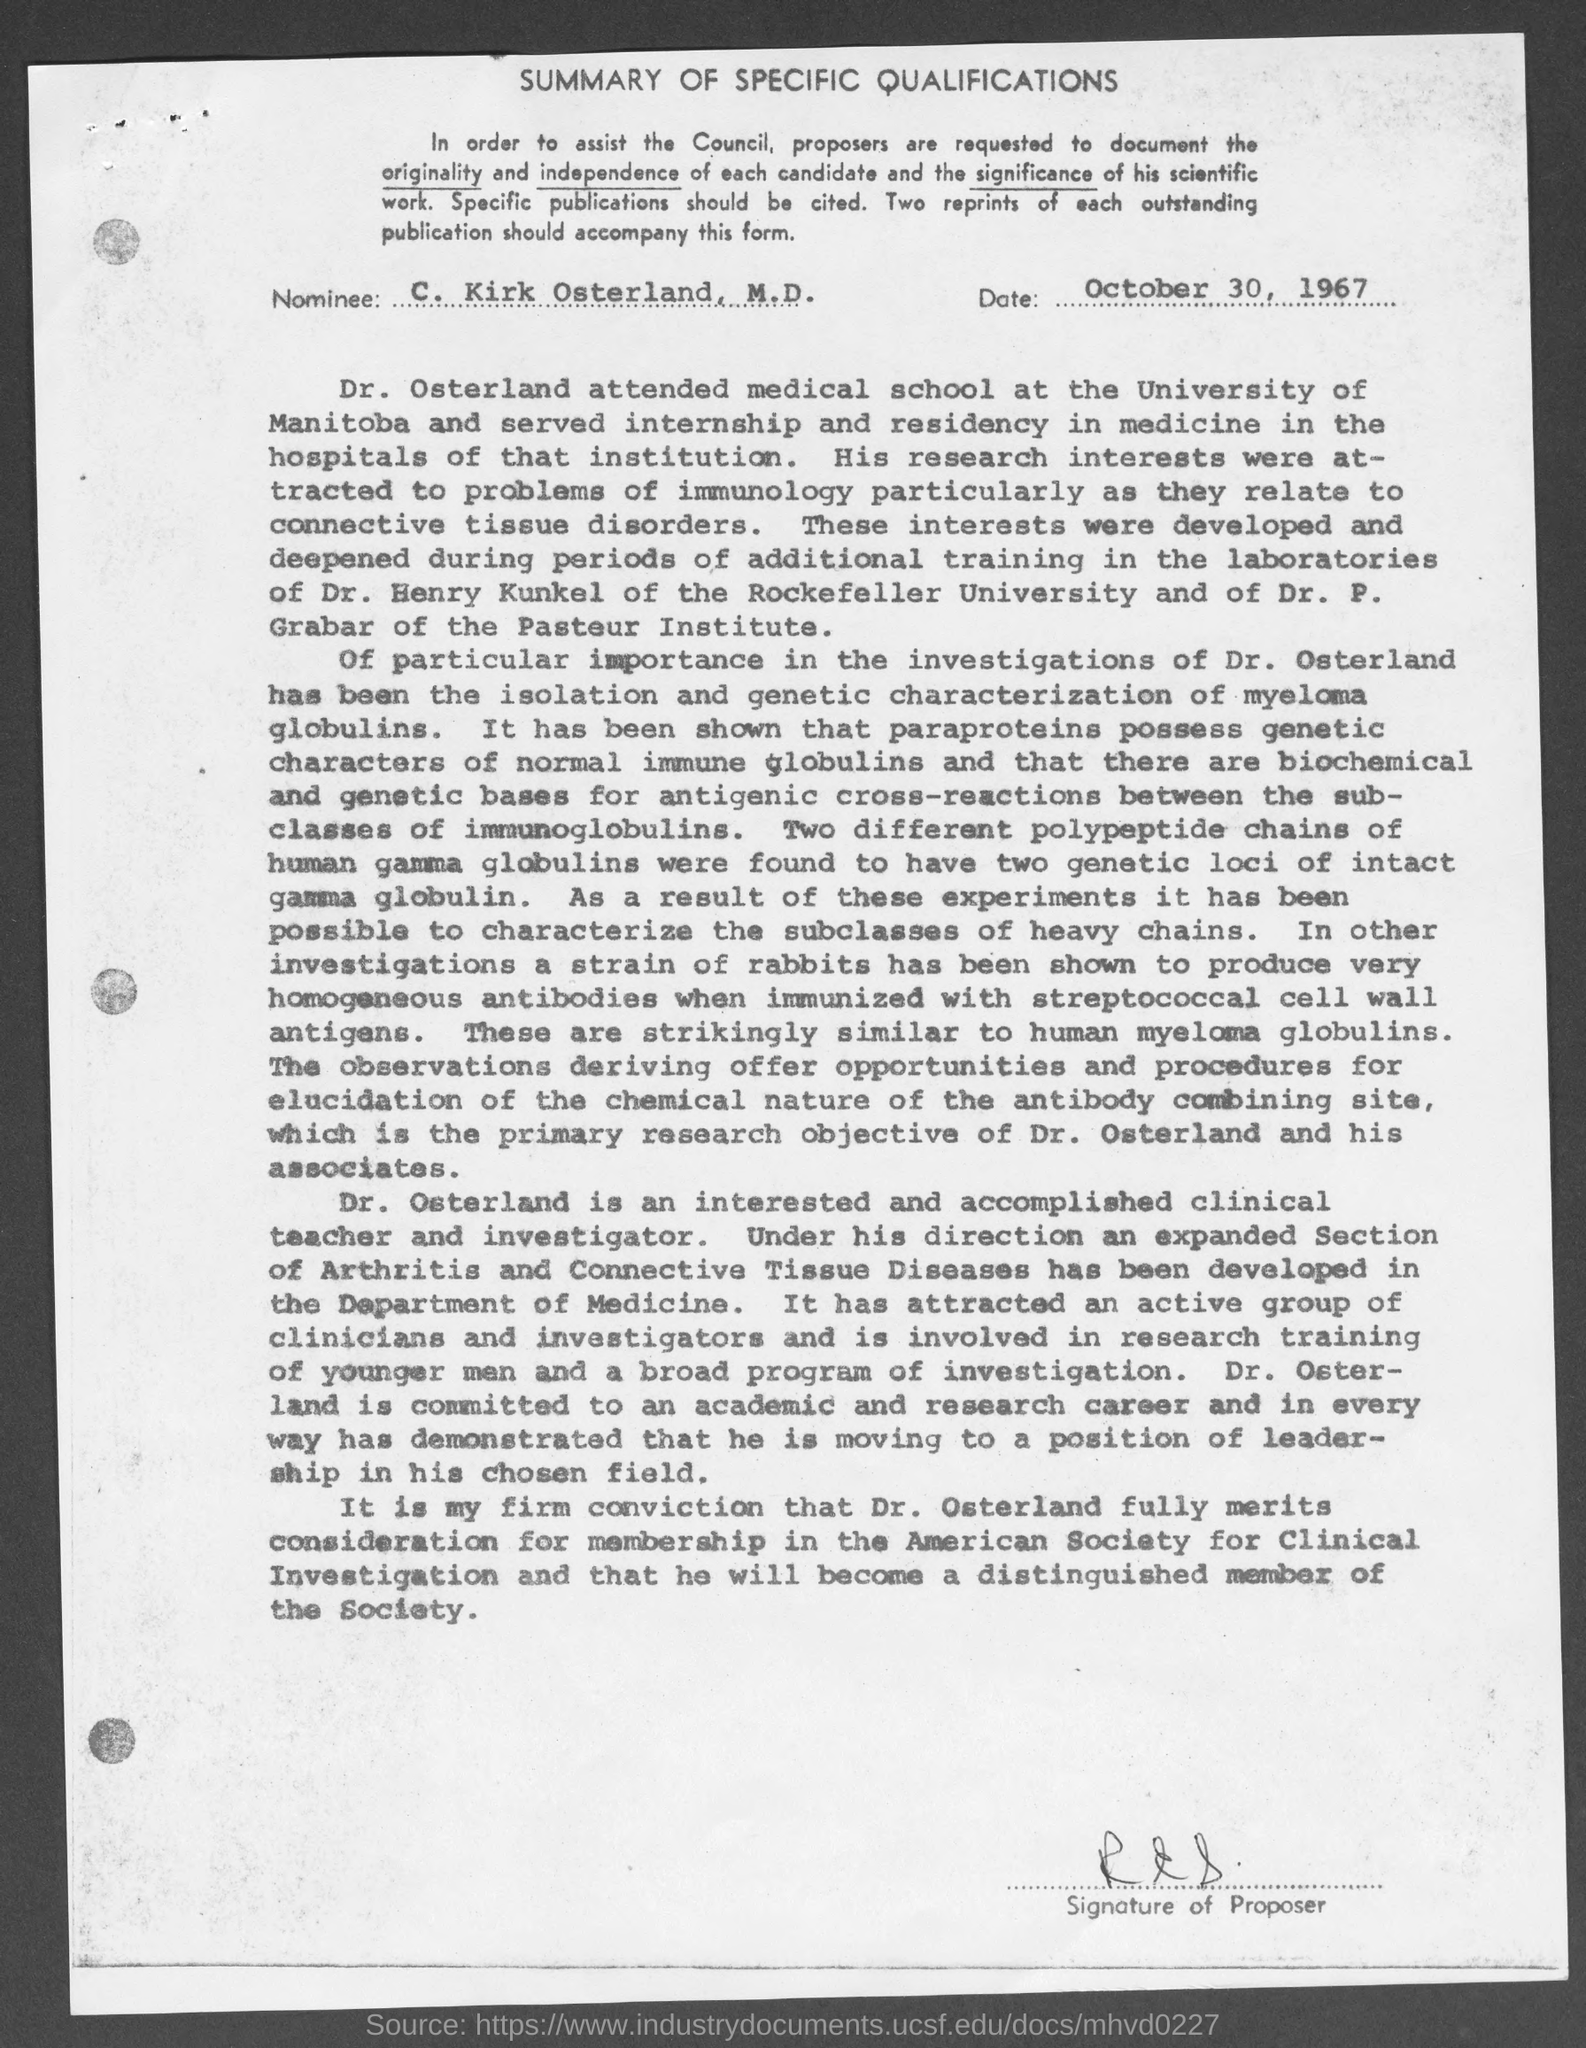Outline some significant characteristics in this image. The nominee mentioned in the document is C. Kirk Osterland. This document is titled [Name of Document]. It provides a summary of the specific qualifications [Name of Person] possesses. The document mentions that the date is October 30, 1967. 